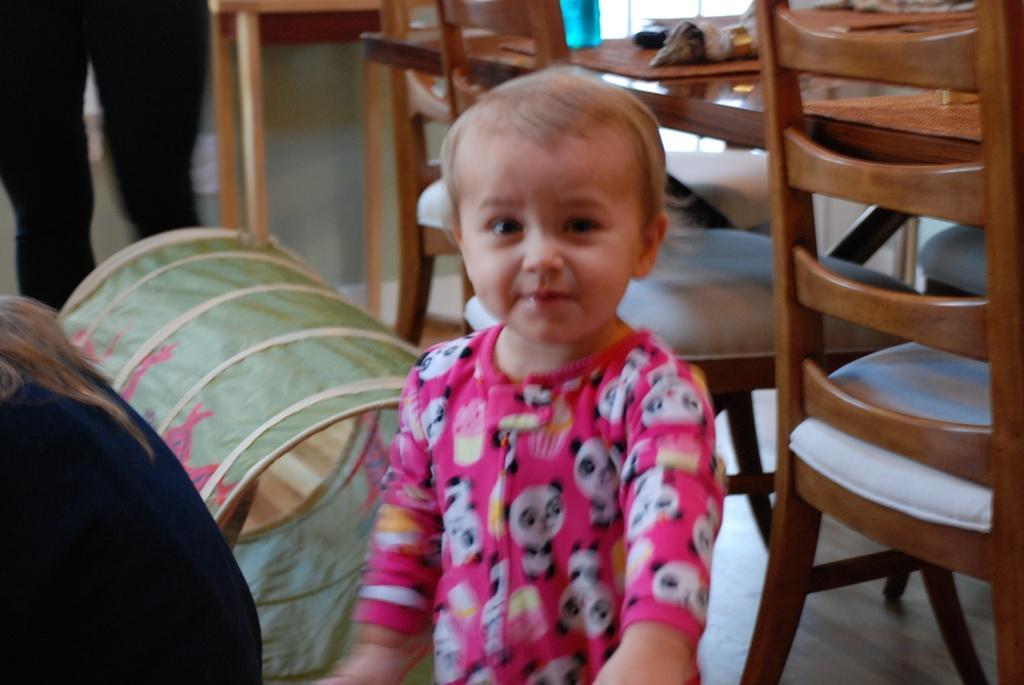How would you summarize this image in a sentence or two? In the center we can see one baby. On the left one more person,on the top we can see one person standing. On the right we can see table and chairs and one barrel. 